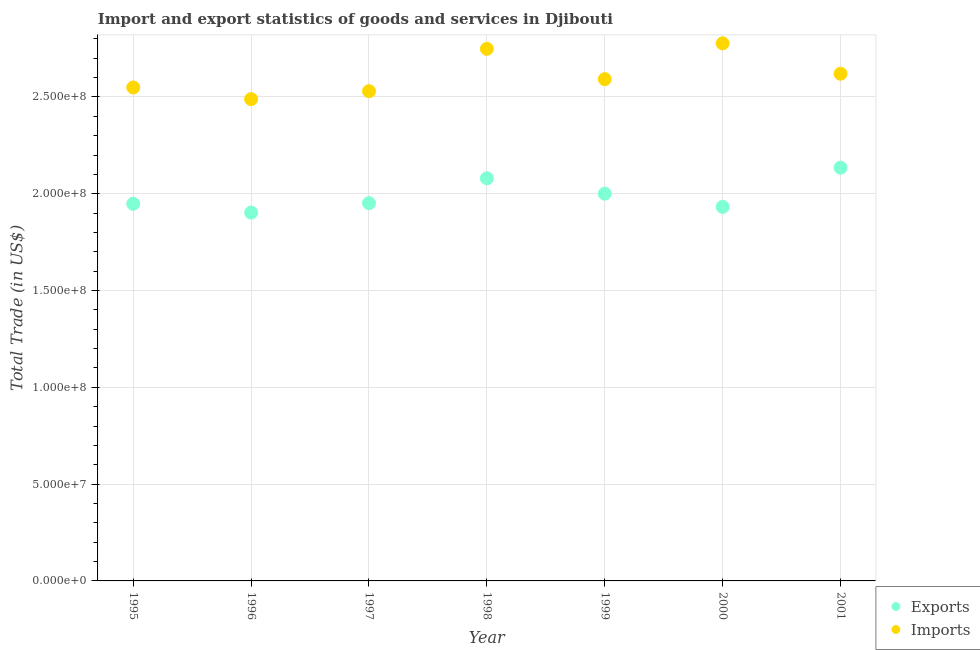Is the number of dotlines equal to the number of legend labels?
Your answer should be compact. Yes. What is the export of goods and services in 1995?
Your answer should be very brief. 1.95e+08. Across all years, what is the maximum imports of goods and services?
Offer a very short reply. 2.78e+08. Across all years, what is the minimum imports of goods and services?
Provide a succinct answer. 2.49e+08. In which year was the imports of goods and services maximum?
Offer a terse response. 2000. What is the total imports of goods and services in the graph?
Your response must be concise. 1.83e+09. What is the difference between the imports of goods and services in 1998 and that in 1999?
Offer a terse response. 1.57e+07. What is the difference between the imports of goods and services in 1999 and the export of goods and services in 1996?
Ensure brevity in your answer.  6.89e+07. What is the average imports of goods and services per year?
Provide a short and direct response. 2.62e+08. In the year 1999, what is the difference between the export of goods and services and imports of goods and services?
Keep it short and to the point. -5.92e+07. In how many years, is the export of goods and services greater than 200000000 US$?
Keep it short and to the point. 3. What is the ratio of the imports of goods and services in 1996 to that in 2000?
Provide a succinct answer. 0.9. Is the imports of goods and services in 1999 less than that in 2000?
Provide a succinct answer. Yes. What is the difference between the highest and the second highest imports of goods and services?
Your response must be concise. 2.83e+06. What is the difference between the highest and the lowest imports of goods and services?
Make the answer very short. 2.88e+07. Is the sum of the export of goods and services in 1998 and 1999 greater than the maximum imports of goods and services across all years?
Your answer should be compact. Yes. Does the export of goods and services monotonically increase over the years?
Provide a succinct answer. No. Is the export of goods and services strictly greater than the imports of goods and services over the years?
Provide a succinct answer. No. Is the export of goods and services strictly less than the imports of goods and services over the years?
Offer a very short reply. Yes. How many dotlines are there?
Your response must be concise. 2. What is the difference between two consecutive major ticks on the Y-axis?
Provide a short and direct response. 5.00e+07. Are the values on the major ticks of Y-axis written in scientific E-notation?
Provide a short and direct response. Yes. Does the graph contain grids?
Keep it short and to the point. Yes. Where does the legend appear in the graph?
Offer a terse response. Bottom right. How many legend labels are there?
Provide a short and direct response. 2. How are the legend labels stacked?
Offer a very short reply. Vertical. What is the title of the graph?
Provide a succinct answer. Import and export statistics of goods and services in Djibouti. Does "Forest" appear as one of the legend labels in the graph?
Provide a short and direct response. No. What is the label or title of the X-axis?
Make the answer very short. Year. What is the label or title of the Y-axis?
Offer a terse response. Total Trade (in US$). What is the Total Trade (in US$) of Exports in 1995?
Give a very brief answer. 1.95e+08. What is the Total Trade (in US$) in Imports in 1995?
Provide a succinct answer. 2.55e+08. What is the Total Trade (in US$) of Exports in 1996?
Ensure brevity in your answer.  1.90e+08. What is the Total Trade (in US$) of Imports in 1996?
Your response must be concise. 2.49e+08. What is the Total Trade (in US$) of Exports in 1997?
Keep it short and to the point. 1.95e+08. What is the Total Trade (in US$) of Imports in 1997?
Provide a succinct answer. 2.53e+08. What is the Total Trade (in US$) of Exports in 1998?
Provide a short and direct response. 2.08e+08. What is the Total Trade (in US$) of Imports in 1998?
Provide a short and direct response. 2.75e+08. What is the Total Trade (in US$) of Exports in 1999?
Offer a terse response. 2.00e+08. What is the Total Trade (in US$) of Imports in 1999?
Keep it short and to the point. 2.59e+08. What is the Total Trade (in US$) in Exports in 2000?
Make the answer very short. 1.93e+08. What is the Total Trade (in US$) of Imports in 2000?
Give a very brief answer. 2.78e+08. What is the Total Trade (in US$) in Exports in 2001?
Give a very brief answer. 2.13e+08. What is the Total Trade (in US$) in Imports in 2001?
Offer a terse response. 2.62e+08. Across all years, what is the maximum Total Trade (in US$) of Exports?
Offer a very short reply. 2.13e+08. Across all years, what is the maximum Total Trade (in US$) in Imports?
Provide a short and direct response. 2.78e+08. Across all years, what is the minimum Total Trade (in US$) of Exports?
Provide a succinct answer. 1.90e+08. Across all years, what is the minimum Total Trade (in US$) of Imports?
Ensure brevity in your answer.  2.49e+08. What is the total Total Trade (in US$) in Exports in the graph?
Your answer should be compact. 1.40e+09. What is the total Total Trade (in US$) of Imports in the graph?
Your answer should be very brief. 1.83e+09. What is the difference between the Total Trade (in US$) of Exports in 1995 and that in 1996?
Ensure brevity in your answer.  4.55e+06. What is the difference between the Total Trade (in US$) of Imports in 1995 and that in 1996?
Ensure brevity in your answer.  6.02e+06. What is the difference between the Total Trade (in US$) of Exports in 1995 and that in 1997?
Your answer should be compact. -3.32e+05. What is the difference between the Total Trade (in US$) in Imports in 1995 and that in 1997?
Ensure brevity in your answer.  1.92e+06. What is the difference between the Total Trade (in US$) of Exports in 1995 and that in 1998?
Make the answer very short. -1.32e+07. What is the difference between the Total Trade (in US$) in Imports in 1995 and that in 1998?
Provide a short and direct response. -2.00e+07. What is the difference between the Total Trade (in US$) of Exports in 1995 and that in 1999?
Provide a succinct answer. -5.21e+06. What is the difference between the Total Trade (in US$) of Imports in 1995 and that in 1999?
Provide a succinct answer. -4.30e+06. What is the difference between the Total Trade (in US$) of Exports in 1995 and that in 2000?
Provide a short and direct response. 1.59e+06. What is the difference between the Total Trade (in US$) of Imports in 1995 and that in 2000?
Your answer should be very brief. -2.28e+07. What is the difference between the Total Trade (in US$) of Exports in 1995 and that in 2001?
Your answer should be very brief. -1.87e+07. What is the difference between the Total Trade (in US$) of Imports in 1995 and that in 2001?
Give a very brief answer. -7.08e+06. What is the difference between the Total Trade (in US$) of Exports in 1996 and that in 1997?
Your answer should be very brief. -4.88e+06. What is the difference between the Total Trade (in US$) of Imports in 1996 and that in 1997?
Offer a terse response. -4.10e+06. What is the difference between the Total Trade (in US$) of Exports in 1996 and that in 1998?
Your answer should be very brief. -1.77e+07. What is the difference between the Total Trade (in US$) in Imports in 1996 and that in 1998?
Provide a short and direct response. -2.60e+07. What is the difference between the Total Trade (in US$) in Exports in 1996 and that in 1999?
Offer a terse response. -9.76e+06. What is the difference between the Total Trade (in US$) of Imports in 1996 and that in 1999?
Give a very brief answer. -1.03e+07. What is the difference between the Total Trade (in US$) of Exports in 1996 and that in 2000?
Give a very brief answer. -2.96e+06. What is the difference between the Total Trade (in US$) of Imports in 1996 and that in 2000?
Provide a short and direct response. -2.88e+07. What is the difference between the Total Trade (in US$) in Exports in 1996 and that in 2001?
Your answer should be very brief. -2.32e+07. What is the difference between the Total Trade (in US$) in Imports in 1996 and that in 2001?
Provide a short and direct response. -1.31e+07. What is the difference between the Total Trade (in US$) of Exports in 1997 and that in 1998?
Offer a terse response. -1.28e+07. What is the difference between the Total Trade (in US$) in Imports in 1997 and that in 1998?
Provide a succinct answer. -2.19e+07. What is the difference between the Total Trade (in US$) in Exports in 1997 and that in 1999?
Make the answer very short. -4.88e+06. What is the difference between the Total Trade (in US$) in Imports in 1997 and that in 1999?
Offer a terse response. -6.22e+06. What is the difference between the Total Trade (in US$) in Exports in 1997 and that in 2000?
Your answer should be compact. 1.92e+06. What is the difference between the Total Trade (in US$) in Imports in 1997 and that in 2000?
Make the answer very short. -2.47e+07. What is the difference between the Total Trade (in US$) in Exports in 1997 and that in 2001?
Your answer should be compact. -1.83e+07. What is the difference between the Total Trade (in US$) in Imports in 1997 and that in 2001?
Make the answer very short. -9.00e+06. What is the difference between the Total Trade (in US$) in Exports in 1998 and that in 1999?
Your response must be concise. 7.96e+06. What is the difference between the Total Trade (in US$) of Imports in 1998 and that in 1999?
Offer a very short reply. 1.57e+07. What is the difference between the Total Trade (in US$) of Exports in 1998 and that in 2000?
Offer a terse response. 1.48e+07. What is the difference between the Total Trade (in US$) in Imports in 1998 and that in 2000?
Make the answer very short. -2.83e+06. What is the difference between the Total Trade (in US$) of Exports in 1998 and that in 2001?
Provide a succinct answer. -5.49e+06. What is the difference between the Total Trade (in US$) in Imports in 1998 and that in 2001?
Your response must be concise. 1.29e+07. What is the difference between the Total Trade (in US$) in Exports in 1999 and that in 2000?
Give a very brief answer. 6.80e+06. What is the difference between the Total Trade (in US$) of Imports in 1999 and that in 2000?
Ensure brevity in your answer.  -1.85e+07. What is the difference between the Total Trade (in US$) of Exports in 1999 and that in 2001?
Make the answer very short. -1.34e+07. What is the difference between the Total Trade (in US$) of Imports in 1999 and that in 2001?
Make the answer very short. -2.78e+06. What is the difference between the Total Trade (in US$) in Exports in 2000 and that in 2001?
Provide a succinct answer. -2.02e+07. What is the difference between the Total Trade (in US$) in Imports in 2000 and that in 2001?
Your response must be concise. 1.57e+07. What is the difference between the Total Trade (in US$) in Exports in 1995 and the Total Trade (in US$) in Imports in 1996?
Your answer should be very brief. -5.41e+07. What is the difference between the Total Trade (in US$) in Exports in 1995 and the Total Trade (in US$) in Imports in 1997?
Ensure brevity in your answer.  -5.82e+07. What is the difference between the Total Trade (in US$) of Exports in 1995 and the Total Trade (in US$) of Imports in 1998?
Offer a terse response. -8.01e+07. What is the difference between the Total Trade (in US$) in Exports in 1995 and the Total Trade (in US$) in Imports in 1999?
Keep it short and to the point. -6.44e+07. What is the difference between the Total Trade (in US$) in Exports in 1995 and the Total Trade (in US$) in Imports in 2000?
Keep it short and to the point. -8.29e+07. What is the difference between the Total Trade (in US$) in Exports in 1995 and the Total Trade (in US$) in Imports in 2001?
Give a very brief answer. -6.72e+07. What is the difference between the Total Trade (in US$) in Exports in 1996 and the Total Trade (in US$) in Imports in 1997?
Offer a terse response. -6.27e+07. What is the difference between the Total Trade (in US$) of Exports in 1996 and the Total Trade (in US$) of Imports in 1998?
Make the answer very short. -8.46e+07. What is the difference between the Total Trade (in US$) of Exports in 1996 and the Total Trade (in US$) of Imports in 1999?
Provide a succinct answer. -6.89e+07. What is the difference between the Total Trade (in US$) of Exports in 1996 and the Total Trade (in US$) of Imports in 2000?
Offer a very short reply. -8.74e+07. What is the difference between the Total Trade (in US$) of Exports in 1996 and the Total Trade (in US$) of Imports in 2001?
Your response must be concise. -7.17e+07. What is the difference between the Total Trade (in US$) in Exports in 1997 and the Total Trade (in US$) in Imports in 1998?
Your answer should be compact. -7.97e+07. What is the difference between the Total Trade (in US$) in Exports in 1997 and the Total Trade (in US$) in Imports in 1999?
Your answer should be very brief. -6.41e+07. What is the difference between the Total Trade (in US$) in Exports in 1997 and the Total Trade (in US$) in Imports in 2000?
Offer a terse response. -8.26e+07. What is the difference between the Total Trade (in US$) in Exports in 1997 and the Total Trade (in US$) in Imports in 2001?
Keep it short and to the point. -6.68e+07. What is the difference between the Total Trade (in US$) in Exports in 1998 and the Total Trade (in US$) in Imports in 1999?
Make the answer very short. -5.12e+07. What is the difference between the Total Trade (in US$) of Exports in 1998 and the Total Trade (in US$) of Imports in 2000?
Your answer should be compact. -6.97e+07. What is the difference between the Total Trade (in US$) in Exports in 1998 and the Total Trade (in US$) in Imports in 2001?
Offer a terse response. -5.40e+07. What is the difference between the Total Trade (in US$) in Exports in 1999 and the Total Trade (in US$) in Imports in 2000?
Offer a terse response. -7.77e+07. What is the difference between the Total Trade (in US$) of Exports in 1999 and the Total Trade (in US$) of Imports in 2001?
Provide a short and direct response. -6.20e+07. What is the difference between the Total Trade (in US$) of Exports in 2000 and the Total Trade (in US$) of Imports in 2001?
Ensure brevity in your answer.  -6.88e+07. What is the average Total Trade (in US$) of Exports per year?
Give a very brief answer. 1.99e+08. What is the average Total Trade (in US$) of Imports per year?
Make the answer very short. 2.62e+08. In the year 1995, what is the difference between the Total Trade (in US$) in Exports and Total Trade (in US$) in Imports?
Offer a terse response. -6.01e+07. In the year 1996, what is the difference between the Total Trade (in US$) of Exports and Total Trade (in US$) of Imports?
Provide a short and direct response. -5.86e+07. In the year 1997, what is the difference between the Total Trade (in US$) in Exports and Total Trade (in US$) in Imports?
Give a very brief answer. -5.78e+07. In the year 1998, what is the difference between the Total Trade (in US$) of Exports and Total Trade (in US$) of Imports?
Ensure brevity in your answer.  -6.69e+07. In the year 1999, what is the difference between the Total Trade (in US$) in Exports and Total Trade (in US$) in Imports?
Offer a terse response. -5.92e+07. In the year 2000, what is the difference between the Total Trade (in US$) of Exports and Total Trade (in US$) of Imports?
Give a very brief answer. -8.45e+07. In the year 2001, what is the difference between the Total Trade (in US$) of Exports and Total Trade (in US$) of Imports?
Make the answer very short. -4.85e+07. What is the ratio of the Total Trade (in US$) of Exports in 1995 to that in 1996?
Ensure brevity in your answer.  1.02. What is the ratio of the Total Trade (in US$) of Imports in 1995 to that in 1996?
Your answer should be very brief. 1.02. What is the ratio of the Total Trade (in US$) in Exports in 1995 to that in 1997?
Your response must be concise. 1. What is the ratio of the Total Trade (in US$) of Imports in 1995 to that in 1997?
Keep it short and to the point. 1.01. What is the ratio of the Total Trade (in US$) of Exports in 1995 to that in 1998?
Offer a terse response. 0.94. What is the ratio of the Total Trade (in US$) in Imports in 1995 to that in 1998?
Make the answer very short. 0.93. What is the ratio of the Total Trade (in US$) in Imports in 1995 to that in 1999?
Give a very brief answer. 0.98. What is the ratio of the Total Trade (in US$) in Exports in 1995 to that in 2000?
Offer a terse response. 1.01. What is the ratio of the Total Trade (in US$) of Imports in 1995 to that in 2000?
Make the answer very short. 0.92. What is the ratio of the Total Trade (in US$) of Exports in 1995 to that in 2001?
Offer a terse response. 0.91. What is the ratio of the Total Trade (in US$) in Exports in 1996 to that in 1997?
Your answer should be very brief. 0.97. What is the ratio of the Total Trade (in US$) in Imports in 1996 to that in 1997?
Provide a short and direct response. 0.98. What is the ratio of the Total Trade (in US$) of Exports in 1996 to that in 1998?
Ensure brevity in your answer.  0.91. What is the ratio of the Total Trade (in US$) in Imports in 1996 to that in 1998?
Make the answer very short. 0.91. What is the ratio of the Total Trade (in US$) of Exports in 1996 to that in 1999?
Your response must be concise. 0.95. What is the ratio of the Total Trade (in US$) in Imports in 1996 to that in 1999?
Your response must be concise. 0.96. What is the ratio of the Total Trade (in US$) of Exports in 1996 to that in 2000?
Your answer should be compact. 0.98. What is the ratio of the Total Trade (in US$) of Imports in 1996 to that in 2000?
Provide a short and direct response. 0.9. What is the ratio of the Total Trade (in US$) in Exports in 1996 to that in 2001?
Give a very brief answer. 0.89. What is the ratio of the Total Trade (in US$) of Imports in 1996 to that in 2001?
Ensure brevity in your answer.  0.95. What is the ratio of the Total Trade (in US$) of Exports in 1997 to that in 1998?
Your answer should be very brief. 0.94. What is the ratio of the Total Trade (in US$) of Imports in 1997 to that in 1998?
Give a very brief answer. 0.92. What is the ratio of the Total Trade (in US$) in Exports in 1997 to that in 1999?
Make the answer very short. 0.98. What is the ratio of the Total Trade (in US$) in Imports in 1997 to that in 1999?
Your answer should be compact. 0.98. What is the ratio of the Total Trade (in US$) in Exports in 1997 to that in 2000?
Your response must be concise. 1.01. What is the ratio of the Total Trade (in US$) of Imports in 1997 to that in 2000?
Offer a terse response. 0.91. What is the ratio of the Total Trade (in US$) of Exports in 1997 to that in 2001?
Your answer should be compact. 0.91. What is the ratio of the Total Trade (in US$) of Imports in 1997 to that in 2001?
Ensure brevity in your answer.  0.97. What is the ratio of the Total Trade (in US$) in Exports in 1998 to that in 1999?
Your response must be concise. 1.04. What is the ratio of the Total Trade (in US$) of Imports in 1998 to that in 1999?
Offer a very short reply. 1.06. What is the ratio of the Total Trade (in US$) of Exports in 1998 to that in 2000?
Offer a very short reply. 1.08. What is the ratio of the Total Trade (in US$) in Exports in 1998 to that in 2001?
Your answer should be very brief. 0.97. What is the ratio of the Total Trade (in US$) of Imports in 1998 to that in 2001?
Your response must be concise. 1.05. What is the ratio of the Total Trade (in US$) of Exports in 1999 to that in 2000?
Offer a very short reply. 1.04. What is the ratio of the Total Trade (in US$) in Imports in 1999 to that in 2000?
Give a very brief answer. 0.93. What is the ratio of the Total Trade (in US$) of Exports in 1999 to that in 2001?
Your answer should be very brief. 0.94. What is the ratio of the Total Trade (in US$) in Imports in 1999 to that in 2001?
Your answer should be very brief. 0.99. What is the ratio of the Total Trade (in US$) of Exports in 2000 to that in 2001?
Give a very brief answer. 0.91. What is the ratio of the Total Trade (in US$) of Imports in 2000 to that in 2001?
Your answer should be compact. 1.06. What is the difference between the highest and the second highest Total Trade (in US$) of Exports?
Your answer should be compact. 5.49e+06. What is the difference between the highest and the second highest Total Trade (in US$) in Imports?
Your answer should be very brief. 2.83e+06. What is the difference between the highest and the lowest Total Trade (in US$) of Exports?
Provide a succinct answer. 2.32e+07. What is the difference between the highest and the lowest Total Trade (in US$) in Imports?
Offer a terse response. 2.88e+07. 